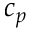<formula> <loc_0><loc_0><loc_500><loc_500>c _ { p }</formula> 